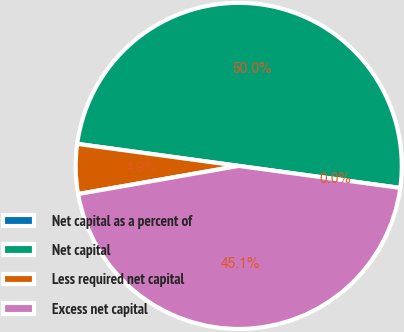Convert chart. <chart><loc_0><loc_0><loc_500><loc_500><pie_chart><fcel>Net capital as a percent of<fcel>Net capital<fcel>Less required net capital<fcel>Excess net capital<nl><fcel>0.0%<fcel>50.0%<fcel>4.92%<fcel>45.08%<nl></chart> 